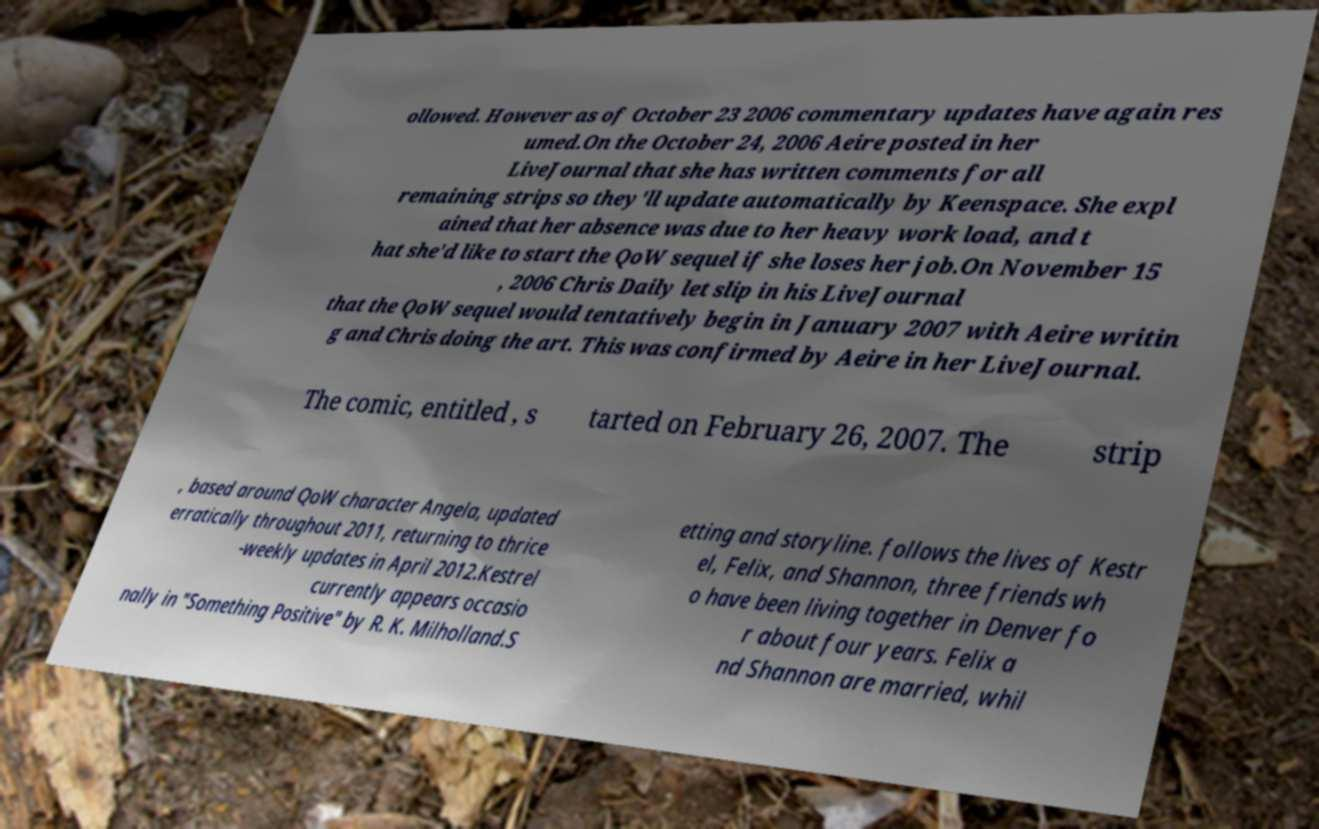Can you accurately transcribe the text from the provided image for me? ollowed. However as of October 23 2006 commentary updates have again res umed.On the October 24, 2006 Aeire posted in her LiveJournal that she has written comments for all remaining strips so they'll update automatically by Keenspace. She expl ained that her absence was due to her heavy work load, and t hat she'd like to start the QoW sequel if she loses her job.On November 15 , 2006 Chris Daily let slip in his LiveJournal that the QoW sequel would tentatively begin in January 2007 with Aeire writin g and Chris doing the art. This was confirmed by Aeire in her LiveJournal. The comic, entitled , s tarted on February 26, 2007. The strip , based around QoW character Angela, updated erratically throughout 2011, returning to thrice -weekly updates in April 2012.Kestrel currently appears occasio nally in "Something Positive" by R. K. Milholland.S etting and storyline. follows the lives of Kestr el, Felix, and Shannon, three friends wh o have been living together in Denver fo r about four years. Felix a nd Shannon are married, whil 